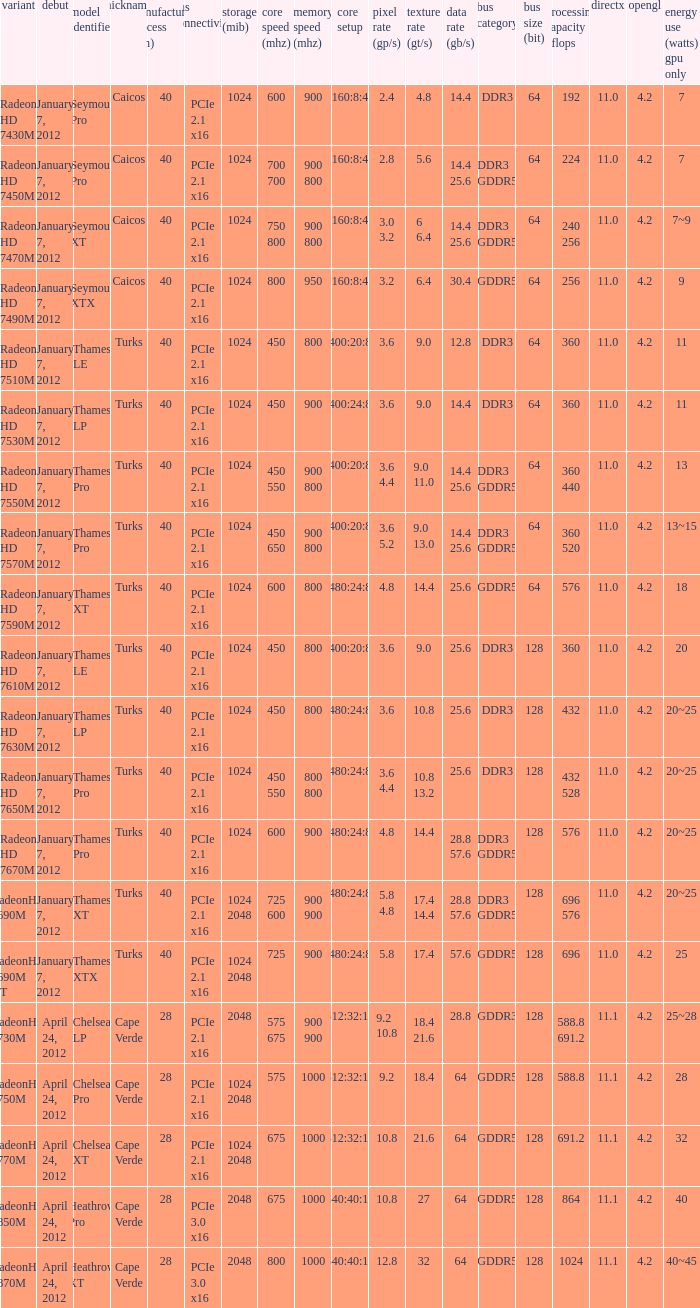What was the model's DirectX if it has a Core of 700 700 mhz? 11.0. 